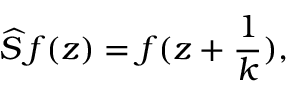<formula> <loc_0><loc_0><loc_500><loc_500>\widehat { S } \, f ( z ) = f ( z + \frac { 1 } { k } ) ,</formula> 